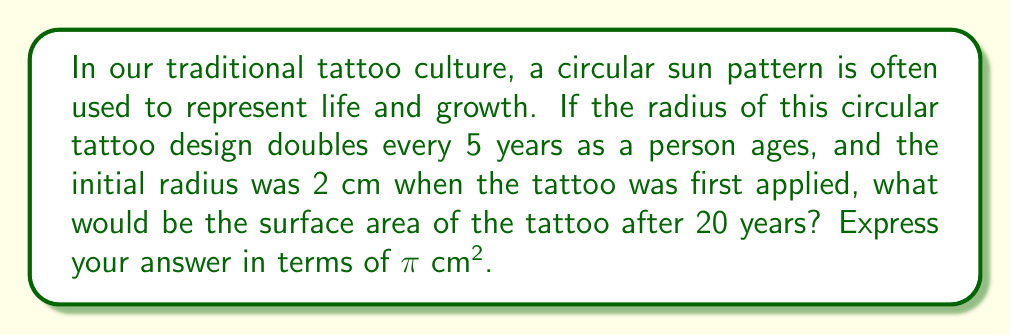Can you answer this question? Let's approach this step-by-step:

1) First, we need to determine how many times the radius has doubled in 20 years:
   20 years ÷ 5 years per doubling = 4 doublings

2) Now, we can calculate the radius after 20 years:
   Initial radius: 2 cm
   After 20 years: $2 \cdot 2^4 = 2 \cdot 16 = 32$ cm

3) The formula for the surface area of a circle is:
   $A = \pi r^2$

4) Substituting our radius:
   $A = \pi (32)^2$

5) Simplifying:
   $A = \pi \cdot 1024 = 1024\pi$ cm²

Therefore, after 20 years, the surface area of the traditional sun tattoo would be $1024\pi$ square centimeters.
Answer: $1024\pi$ cm² 